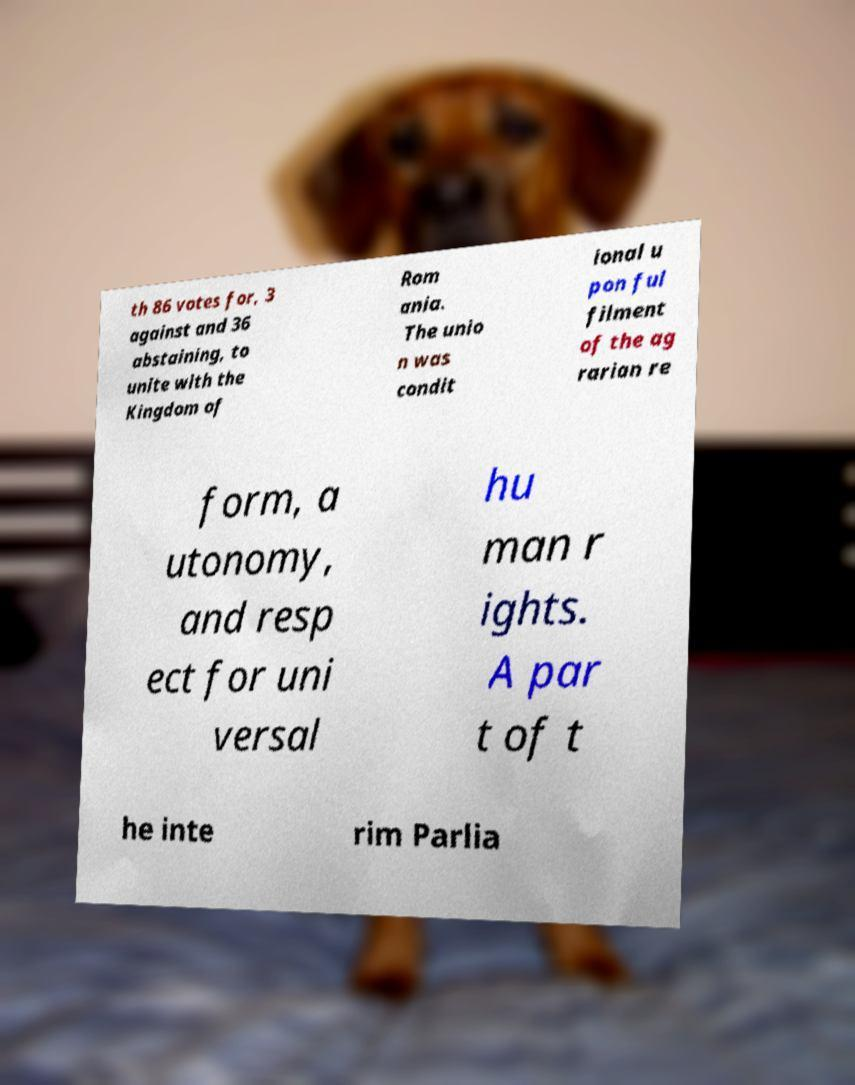Please read and relay the text visible in this image. What does it say? th 86 votes for, 3 against and 36 abstaining, to unite with the Kingdom of Rom ania. The unio n was condit ional u pon ful filment of the ag rarian re form, a utonomy, and resp ect for uni versal hu man r ights. A par t of t he inte rim Parlia 